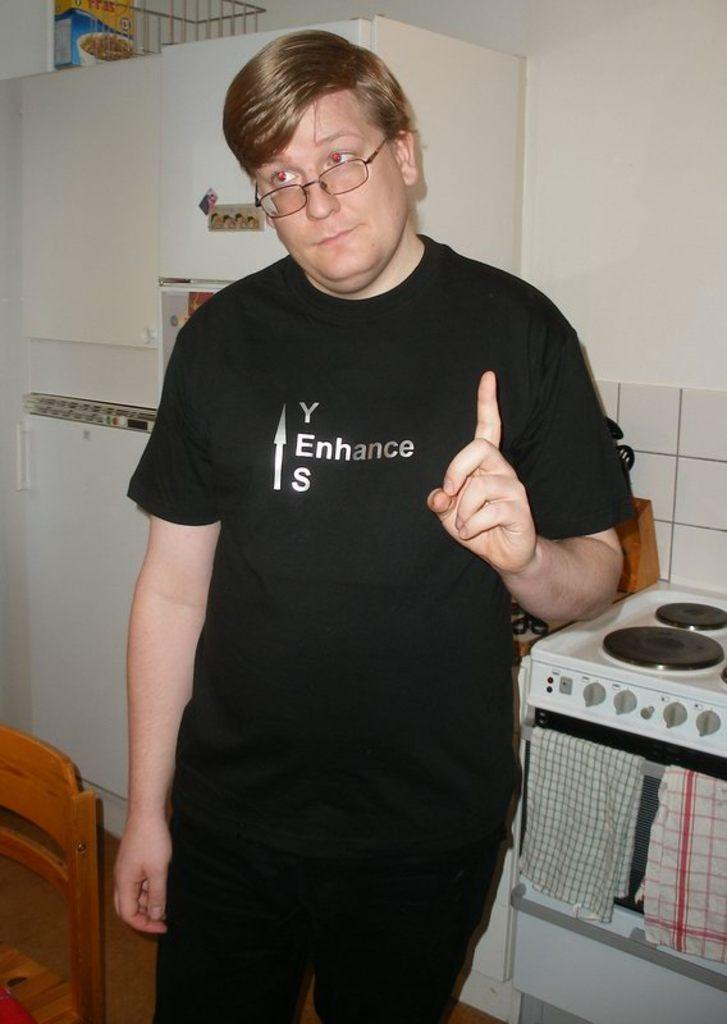<image>
Present a compact description of the photo's key features. A young man's black t-shirt has Yes Enhance on it. 